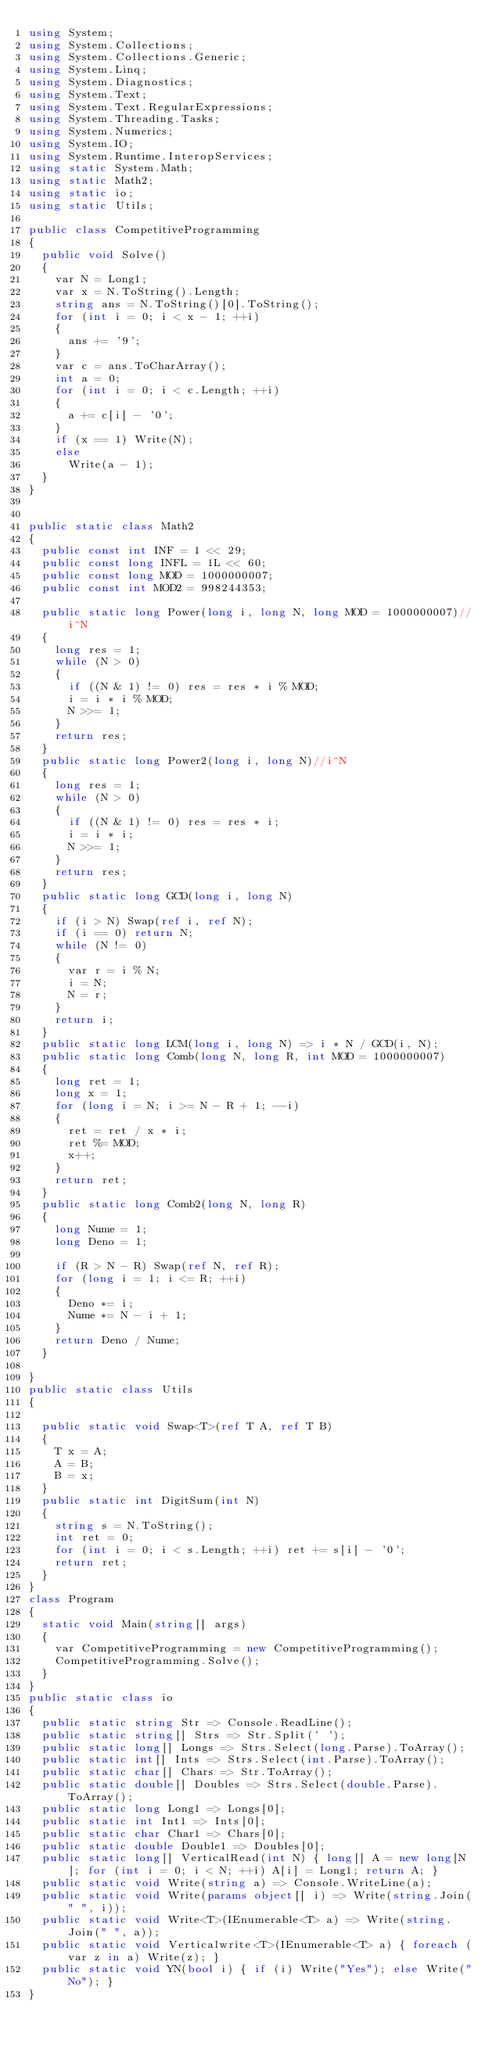<code> <loc_0><loc_0><loc_500><loc_500><_C#_>using System;
using System.Collections;
using System.Collections.Generic;
using System.Linq;
using System.Diagnostics;
using System.Text;
using System.Text.RegularExpressions;
using System.Threading.Tasks;
using System.Numerics;
using System.IO;
using System.Runtime.InteropServices;
using static System.Math;
using static Math2;
using static io;
using static Utils;

public class CompetitiveProgramming
{
  public void Solve()
  {
    var N = Long1;
    var x = N.ToString().Length;
    string ans = N.ToString()[0].ToString();
    for (int i = 0; i < x - 1; ++i)
    {
      ans += '9';
    }
    var c = ans.ToCharArray();
    int a = 0;
    for (int i = 0; i < c.Length; ++i)
    {
      a += c[i] - '0';
    }
    if (x == 1) Write(N);
    else
      Write(a - 1);
  }
}


public static class Math2
{
  public const int INF = 1 << 29;
  public const long INFL = 1L << 60;
  public const long MOD = 1000000007;
  public const int MOD2 = 998244353;

  public static long Power(long i, long N, long MOD = 1000000007)//i^N
  {
    long res = 1;
    while (N > 0)
    {
      if ((N & 1) != 0) res = res * i % MOD;
      i = i * i % MOD;
      N >>= 1;
    }
    return res;
  }
  public static long Power2(long i, long N)//i^N
  {
    long res = 1;
    while (N > 0)
    {
      if ((N & 1) != 0) res = res * i;
      i = i * i;
      N >>= 1;
    }
    return res;
  }
  public static long GCD(long i, long N)
  {
    if (i > N) Swap(ref i, ref N);
    if (i == 0) return N;
    while (N != 0)
    {
      var r = i % N;
      i = N;
      N = r;
    }
    return i;
  }
  public static long LCM(long i, long N) => i * N / GCD(i, N);
  public static long Comb(long N, long R, int MOD = 1000000007)
  {
    long ret = 1;
    long x = 1;
    for (long i = N; i >= N - R + 1; --i)
    {
      ret = ret / x * i;
      ret %= MOD;
      x++;
    }
    return ret;
  }
  public static long Comb2(long N, long R)
  {
    long Nume = 1;
    long Deno = 1;

    if (R > N - R) Swap(ref N, ref R);
    for (long i = 1; i <= R; ++i)
    {
      Deno *= i;
      Nume *= N - i + 1;
    }
    return Deno / Nume;
  }

}
public static class Utils
{

  public static void Swap<T>(ref T A, ref T B)
  {
    T x = A;
    A = B;
    B = x;
  }
  public static int DigitSum(int N)
  {
    string s = N.ToString();
    int ret = 0;
    for (int i = 0; i < s.Length; ++i) ret += s[i] - '0';
    return ret;
  }
}
class Program
{
  static void Main(string[] args)
  {
    var CompetitiveProgramming = new CompetitiveProgramming();
    CompetitiveProgramming.Solve();
  }
}
public static class io
{
  public static string Str => Console.ReadLine();
  public static string[] Strs => Str.Split(' ');
  public static long[] Longs => Strs.Select(long.Parse).ToArray();
  public static int[] Ints => Strs.Select(int.Parse).ToArray();
  public static char[] Chars => Str.ToArray();
  public static double[] Doubles => Strs.Select(double.Parse).ToArray();
  public static long Long1 => Longs[0];
  public static int Int1 => Ints[0];
  public static char Char1 => Chars[0];
  public static double Double1 => Doubles[0];
  public static long[] VerticalRead(int N) { long[] A = new long[N]; for (int i = 0; i < N; ++i) A[i] = Long1; return A; }
  public static void Write(string a) => Console.WriteLine(a);
  public static void Write(params object[] i) => Write(string.Join(" ", i));
  public static void Write<T>(IEnumerable<T> a) => Write(string.Join(" ", a));
  public static void Verticalwrite<T>(IEnumerable<T> a) { foreach (var z in a) Write(z); }
  public static void YN(bool i) { if (i) Write("Yes"); else Write("No"); }
}
</code> 